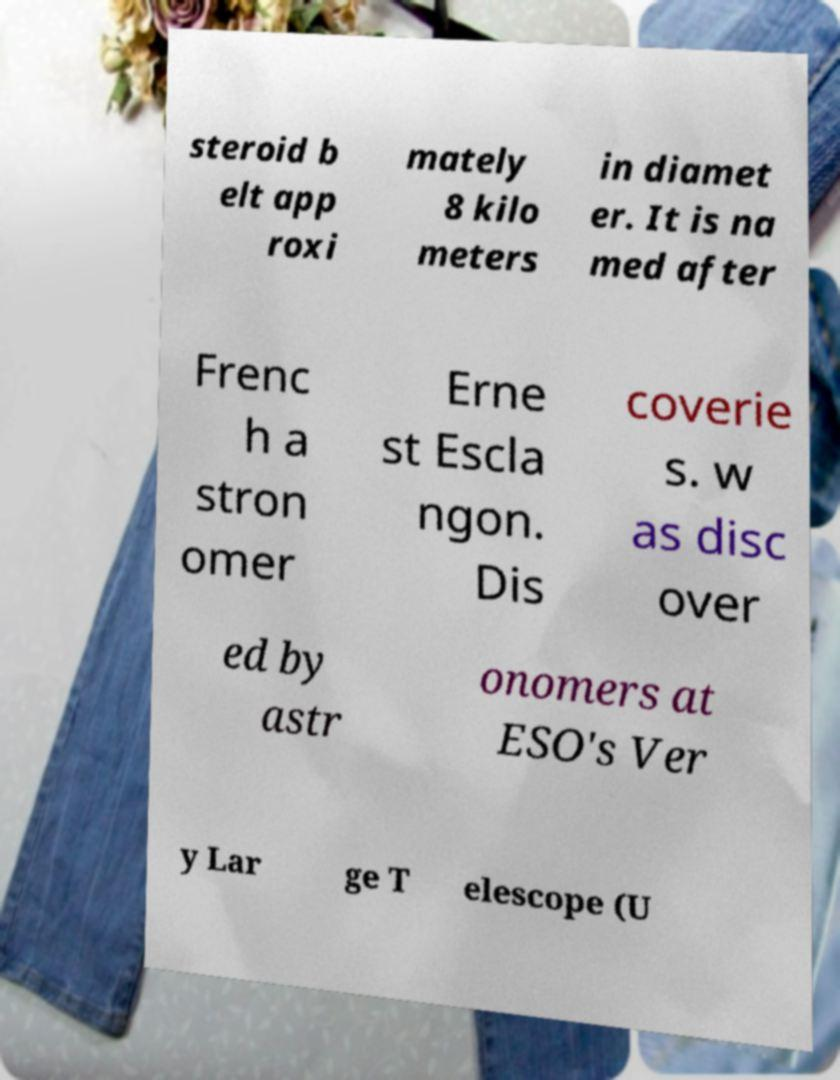There's text embedded in this image that I need extracted. Can you transcribe it verbatim? steroid b elt app roxi mately 8 kilo meters in diamet er. It is na med after Frenc h a stron omer Erne st Escla ngon. Dis coverie s. w as disc over ed by astr onomers at ESO's Ver y Lar ge T elescope (U 